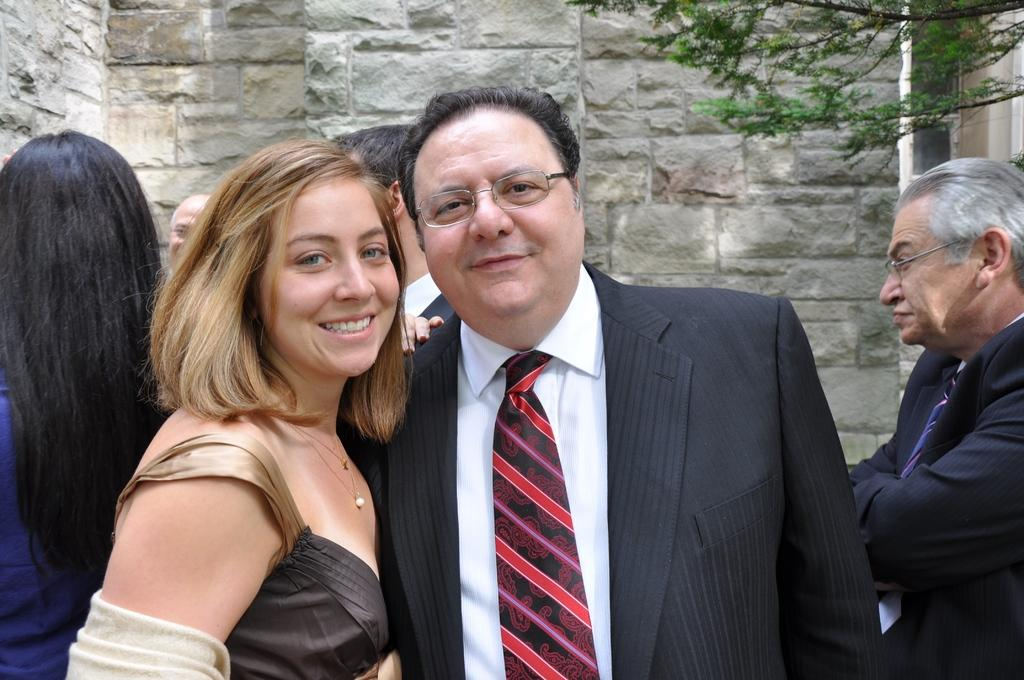How many people are visible in the image? There are two persons standing in the image. What is the facial expression of the persons in the image? Both persons have a smile on their face. Can you describe the background of the image? There is a tree and a wall in the background of the image. Are there any other people visible in the image besides the two main persons? Yes, there are other few people standing in the background. What color is the crayon being used by the person in the image? There is no crayon present in the image. Is the scarf being worn by the person in the image? There is no scarf visible on the persons in the image. 